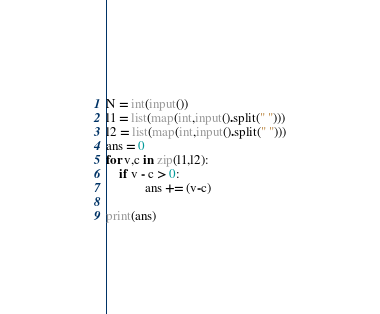Convert code to text. <code><loc_0><loc_0><loc_500><loc_500><_Python_>N = int(input())
l1 = list(map(int,input().split(" ")))
l2 = list(map(int,input().split(" ")))
ans = 0
for v,c in zip(l1,l2):
    if v - c > 0:
            ans += (v-c)

print(ans)    </code> 